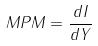<formula> <loc_0><loc_0><loc_500><loc_500>M P M = \frac { d I } { d Y }</formula> 